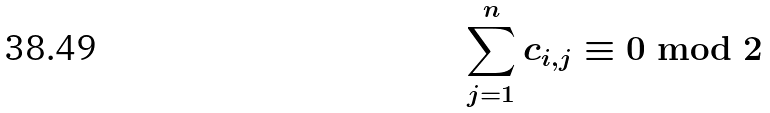Convert formula to latex. <formula><loc_0><loc_0><loc_500><loc_500>\sum _ { j = 1 } ^ { n } c _ { i , j } \equiv 0 \bmod { 2 }</formula> 